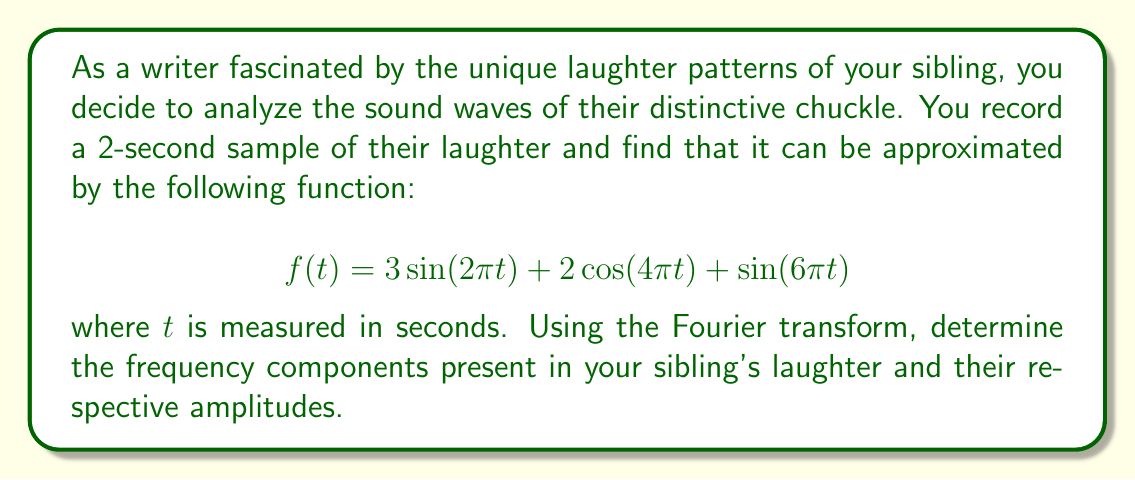Can you answer this question? To solve this problem, we'll use the properties of the Fourier transform and the given function to identify the frequency components and their amplitudes.

1. Recall that the Fourier transform of a sine wave $A\sin(2\pi ft)$ is:
   $$\mathcal{F}\{A\sin(2\pi ft)\} = \frac{iA}{2}[\delta(f') - \delta(f'+f)] - \frac{iA}{2}[\delta(f'-f) - \delta(f')]$$
   where $f'$ is the frequency variable in the Fourier domain.

2. Similarly, the Fourier transform of a cosine wave $A\cos(2\pi ft)$ is:
   $$\mathcal{F}\{A\cos(2\pi ft)\} = \frac{A}{2}[\delta(f'-f) + \delta(f'+f)]$$

3. Now, let's break down the given function:
   a) $3\sin(2\pi t)$: Amplitude = 3, Frequency = 1 Hz
   b) $2\cos(4\pi t)$: Amplitude = 2, Frequency = 2 Hz
   c) $\sin(6\pi t)$: Amplitude = 1, Frequency = 3 Hz

4. Using the linearity property of the Fourier transform, we can transform each term separately and combine the results.

5. The Fourier transform of the entire function will be:
   $$\mathcal{F}\{f(t)\} = \frac{3i}{2}[\delta(f'-1) - \delta(f'+1)] - \frac{3i}{2}[\delta(f'-1) - \delta(f')] + [\delta(f'-2) + \delta(f'+2)] + \frac{i}{2}[\delta(f'-3) - \delta(f'+3)] - \frac{i}{2}[\delta(f'-3) - \delta(f')]$$

6. To find the amplitude of each frequency component, we need to look at the coefficients of the delta functions for positive frequencies:
   - At $f' = 1$ Hz: Amplitude = 3
   - At $f' = 2$ Hz: Amplitude = 2
   - At $f' = 3$ Hz: Amplitude = 1

Therefore, the frequency components present in your sibling's laughter are 1 Hz, 2 Hz, and 3 Hz, with amplitudes 3, 2, and 1, respectively.
Answer: The frequency components and their amplitudes in the sibling's laughter are:
1 Hz with amplitude 3
2 Hz with amplitude 2
3 Hz with amplitude 1 